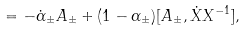Convert formula to latex. <formula><loc_0><loc_0><loc_500><loc_500>= - \dot { \alpha } _ { \pm } A _ { \pm } + ( 1 - \alpha _ { \pm } ) [ A _ { \pm } , \dot { X } X ^ { - 1 } ] ,</formula> 